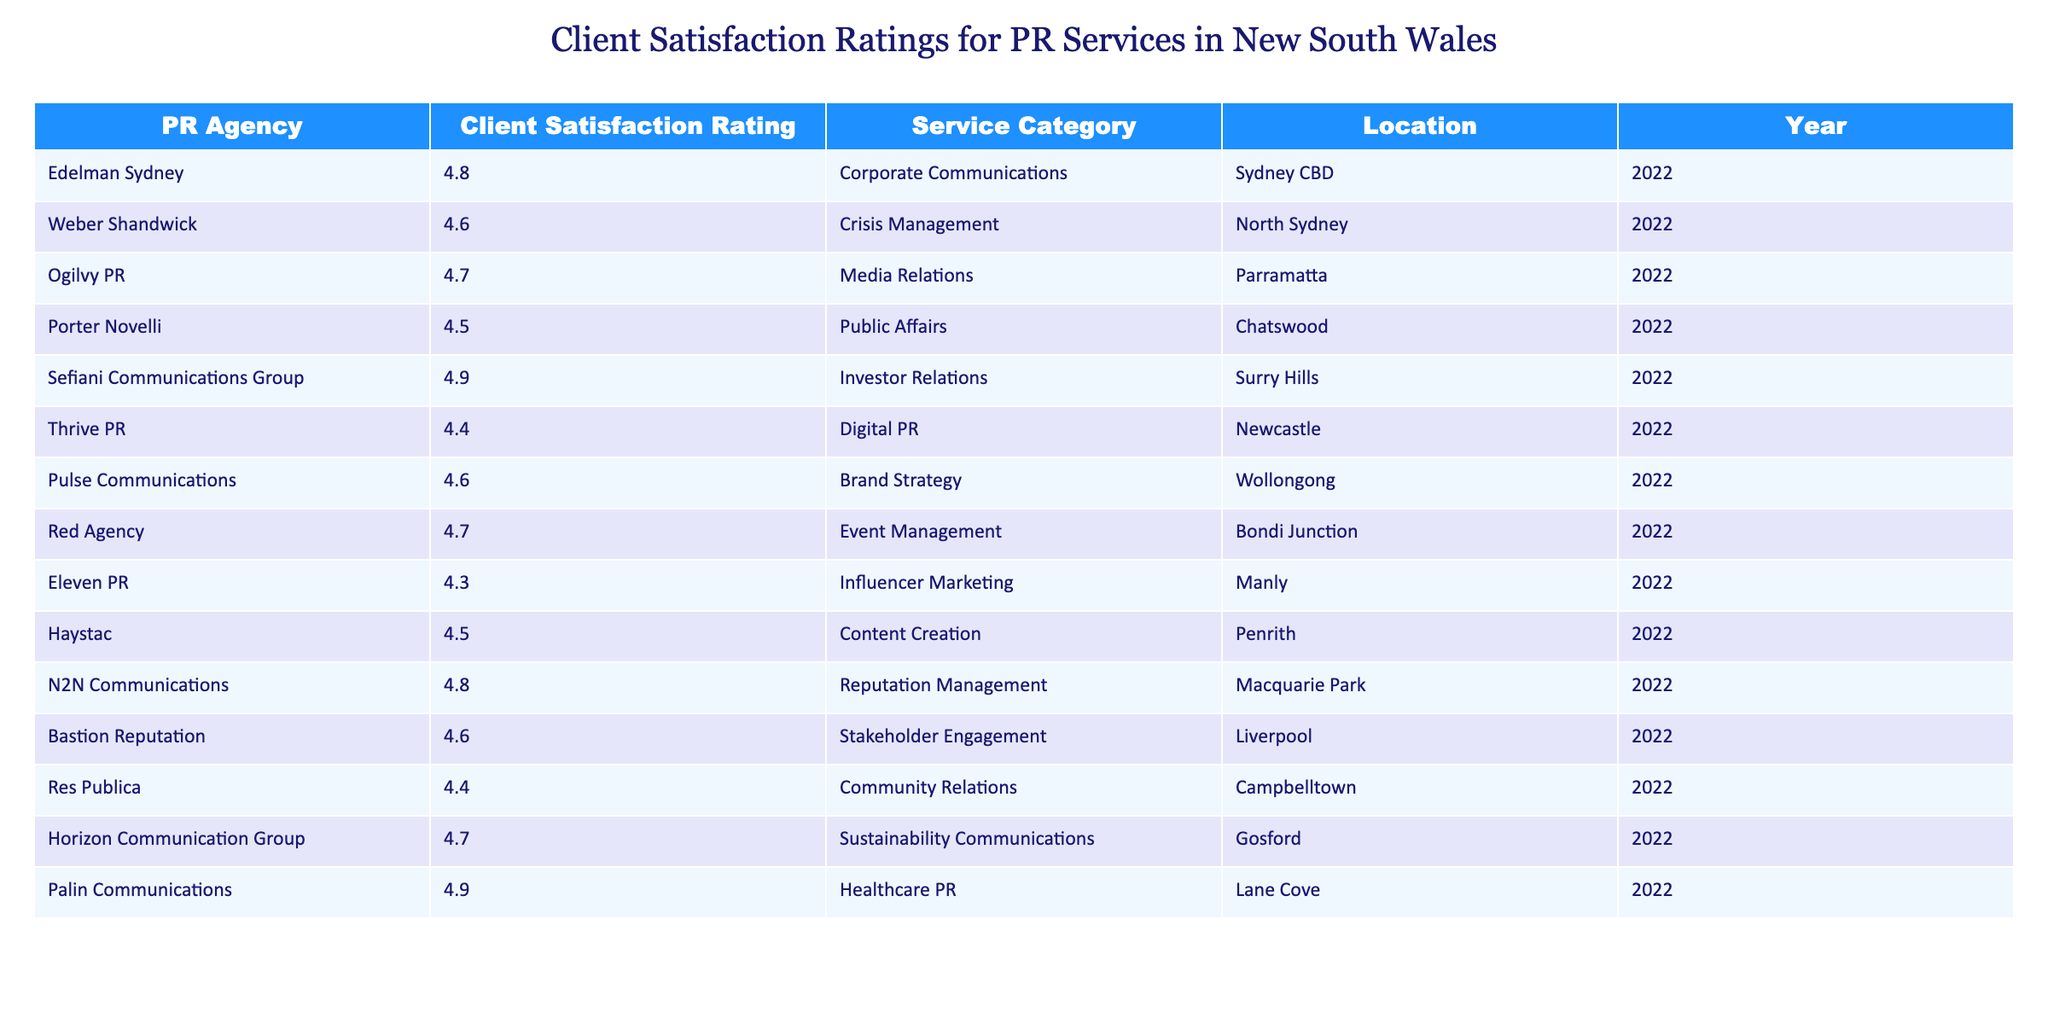What is the client satisfaction rating for Sefiani Communications Group? Sefiani Communications Group has a client satisfaction rating listed in the table, which is 4.9.
Answer: 4.9 Which PR agency located in Parramatta has a satisfaction rating of 4.7? The agency located in Parramatta is Ogilvy PR, which has a satisfaction rating of 4.7.
Answer: Ogilvy PR What is the average client satisfaction rating for the listed PR agencies? To find the average, we sum all the ratings: 4.8 + 4.6 + 4.7 + 4.5 + 4.9 + 4.4 + 4.6 + 4.7 + 4.3 + 4.5 + 4.8 + 4.6 + 4.4 + 4.7 + 4.9 = 68.6, then divide by 15 (the number of agencies) to get 68.6 / 15 = 4.573.
Answer: 4.57 Is there a PR agency located in North Sydney that has a rating lower than 4.6? Yes, Weber Shandwick is located in North Sydney and has a rating of 4.6, which is not lower than 4.6. Thus, the answer is false.
Answer: False Which PR agency has the highest rating and in which location is it based? Sefiani Communications Group has the highest rating of 4.9, and it is based in Surry Hills.
Answer: Sefiani Communications Group in Surry Hills How many PR agencies have a satisfaction rating of 4.5 or lower? The given ratings that are 4.5 or lower are for Thrive PR (4.4), Eleven PR (4.3), and Haystac (4.5). Thus, there are 3 agencies with ratings of 4.5 or lower.
Answer: 3 Which service category has the lowest client satisfaction rating? The ratings for each service category indicate that Influencer Marketing (Eleven PR) has the lowest rating of 4.3, which is lower than any other category.
Answer: Influencer Marketing Is there a PR agency that specializes in Healthcare PR with a rating of 4.9? Yes, Palin Communications has a specialization in Healthcare PR and a rating of 4.9.
Answer: Yes What is the difference in client satisfaction ratings between the best and worst rated PR agencies? The best rating is 4.9 (Sefiani Communications Group) and the worst is 4.3 (Eleven PR). The difference is 4.9 - 4.3 = 0.6.
Answer: 0.6 Which two locations have PR agencies with the same satisfaction rating of 4.6? The locations with PR agencies that both have a rating of 4.6 are North Sydney (Weber Shandwick) and Bastion Reputation in Liverpool.
Answer: North Sydney and Liverpool 